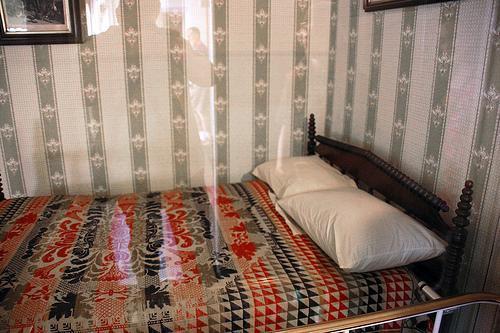How many pillows are there?
Give a very brief answer. 2. 